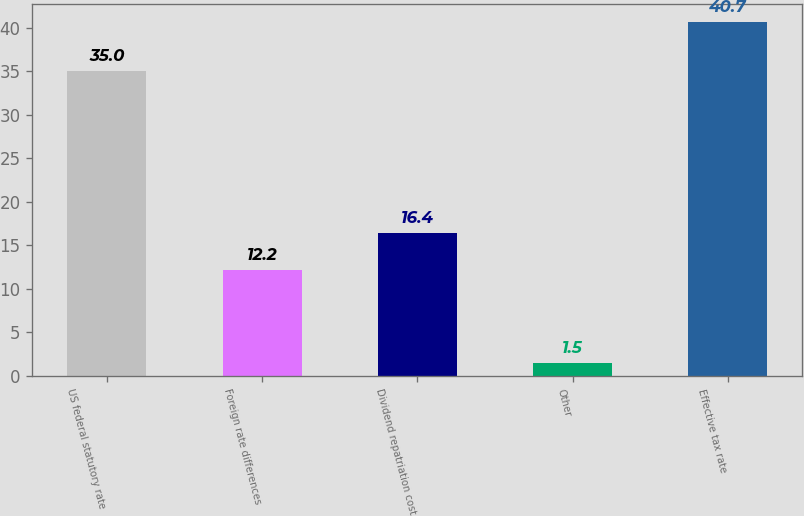Convert chart. <chart><loc_0><loc_0><loc_500><loc_500><bar_chart><fcel>US federal statutory rate<fcel>Foreign rate differences<fcel>Dividend repatriation cost<fcel>Other<fcel>Effective tax rate<nl><fcel>35<fcel>12.2<fcel>16.4<fcel>1.5<fcel>40.7<nl></chart> 